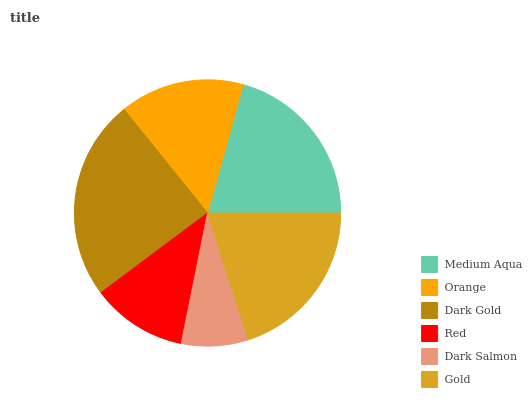Is Dark Salmon the minimum?
Answer yes or no. Yes. Is Dark Gold the maximum?
Answer yes or no. Yes. Is Orange the minimum?
Answer yes or no. No. Is Orange the maximum?
Answer yes or no. No. Is Medium Aqua greater than Orange?
Answer yes or no. Yes. Is Orange less than Medium Aqua?
Answer yes or no. Yes. Is Orange greater than Medium Aqua?
Answer yes or no. No. Is Medium Aqua less than Orange?
Answer yes or no. No. Is Gold the high median?
Answer yes or no. Yes. Is Orange the low median?
Answer yes or no. Yes. Is Dark Salmon the high median?
Answer yes or no. No. Is Dark Gold the low median?
Answer yes or no. No. 